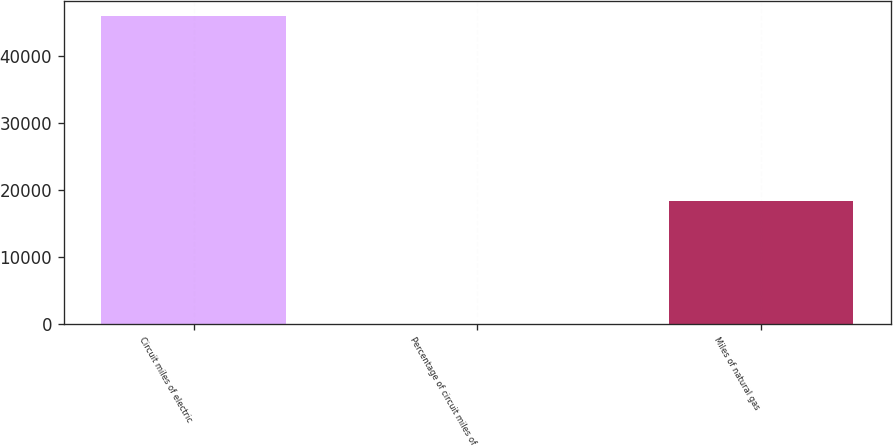Convert chart to OTSL. <chart><loc_0><loc_0><loc_500><loc_500><bar_chart><fcel>Circuit miles of electric<fcel>Percentage of circuit miles of<fcel>Miles of natural gas<nl><fcel>45881<fcel>15<fcel>18294<nl></chart> 